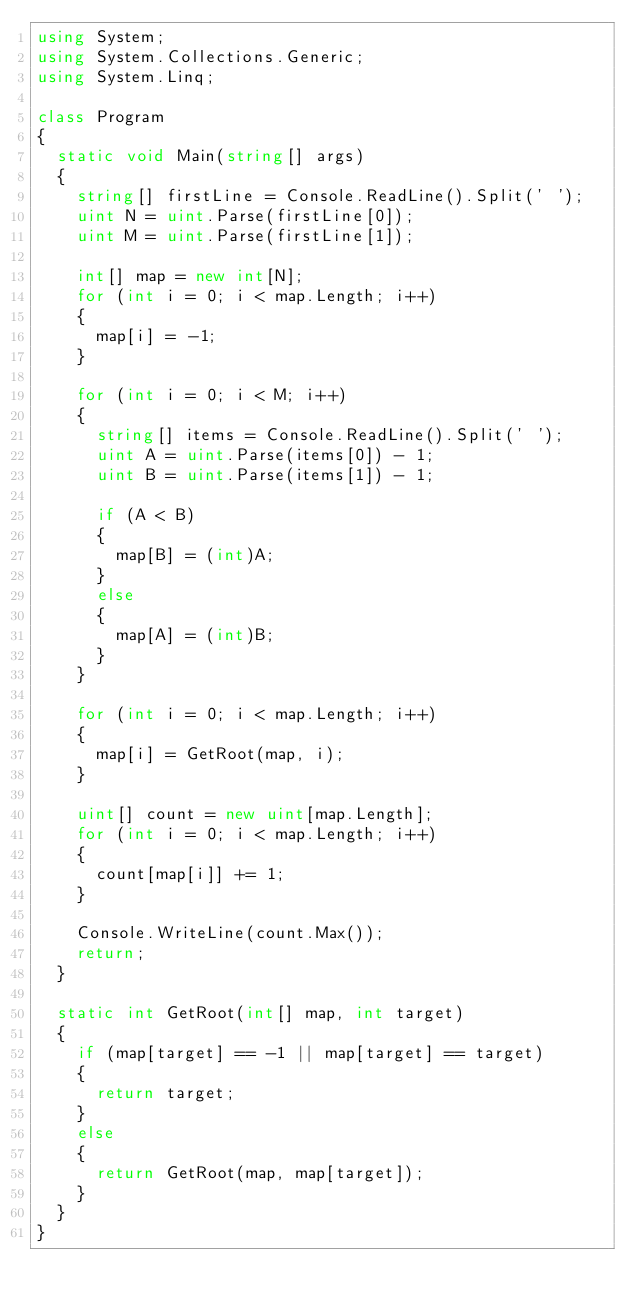<code> <loc_0><loc_0><loc_500><loc_500><_C#_>using System;
using System.Collections.Generic;
using System.Linq;

class Program
{
  static void Main(string[] args)
  {
    string[] firstLine = Console.ReadLine().Split(' ');
    uint N = uint.Parse(firstLine[0]);
    uint M = uint.Parse(firstLine[1]);

    int[] map = new int[N];
    for (int i = 0; i < map.Length; i++)
    {
      map[i] = -1;
    }

    for (int i = 0; i < M; i++)
    {
      string[] items = Console.ReadLine().Split(' ');
      uint A = uint.Parse(items[0]) - 1;
      uint B = uint.Parse(items[1]) - 1;

      if (A < B)
      {
        map[B] = (int)A;
      }
      else
      {
        map[A] = (int)B;
      }
    }

    for (int i = 0; i < map.Length; i++)
    {
      map[i] = GetRoot(map, i);
    }

    uint[] count = new uint[map.Length];
    for (int i = 0; i < map.Length; i++)
    {
      count[map[i]] += 1;
    }

    Console.WriteLine(count.Max());
    return;
  }

  static int GetRoot(int[] map, int target)
  {
    if (map[target] == -1 || map[target] == target)
    {
      return target;
    }
    else
    {
      return GetRoot(map, map[target]);
    }
  }
}</code> 